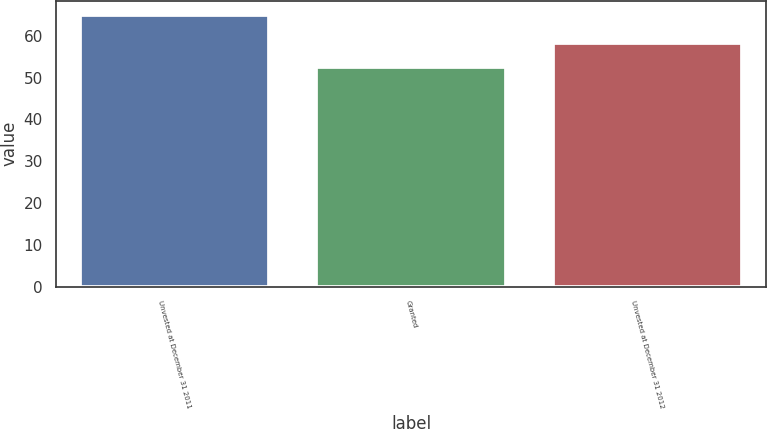Convert chart to OTSL. <chart><loc_0><loc_0><loc_500><loc_500><bar_chart><fcel>Unvested at December 31 2011<fcel>Granted<fcel>Unvested at December 31 2012<nl><fcel>65.1<fcel>52.6<fcel>58.25<nl></chart> 